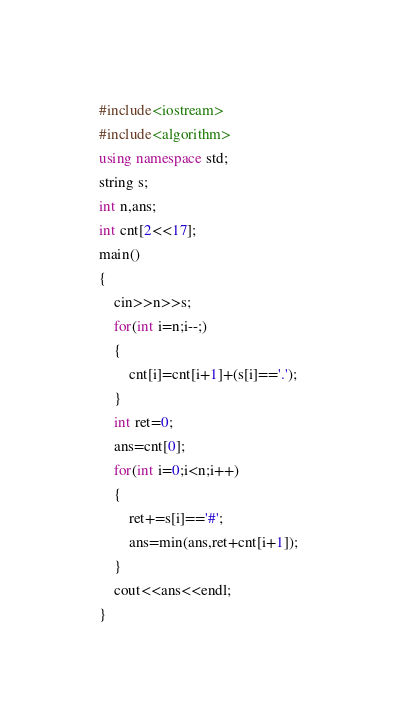<code> <loc_0><loc_0><loc_500><loc_500><_C++_>#include<iostream>
#include<algorithm>
using namespace std;
string s;
int n,ans;
int cnt[2<<17];
main()
{
	cin>>n>>s;
	for(int i=n;i--;)
	{
		cnt[i]=cnt[i+1]+(s[i]=='.');
	}
	int ret=0;
	ans=cnt[0];
	for(int i=0;i<n;i++)
	{
		ret+=s[i]=='#';
		ans=min(ans,ret+cnt[i+1]);
	}
	cout<<ans<<endl;
}
</code> 